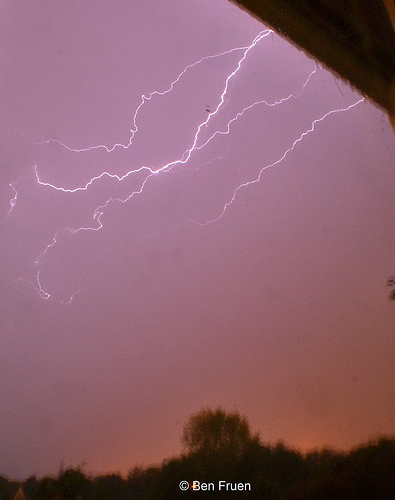<image>
Is there a lightening in the sky? Yes. The lightening is contained within or inside the sky, showing a containment relationship. 